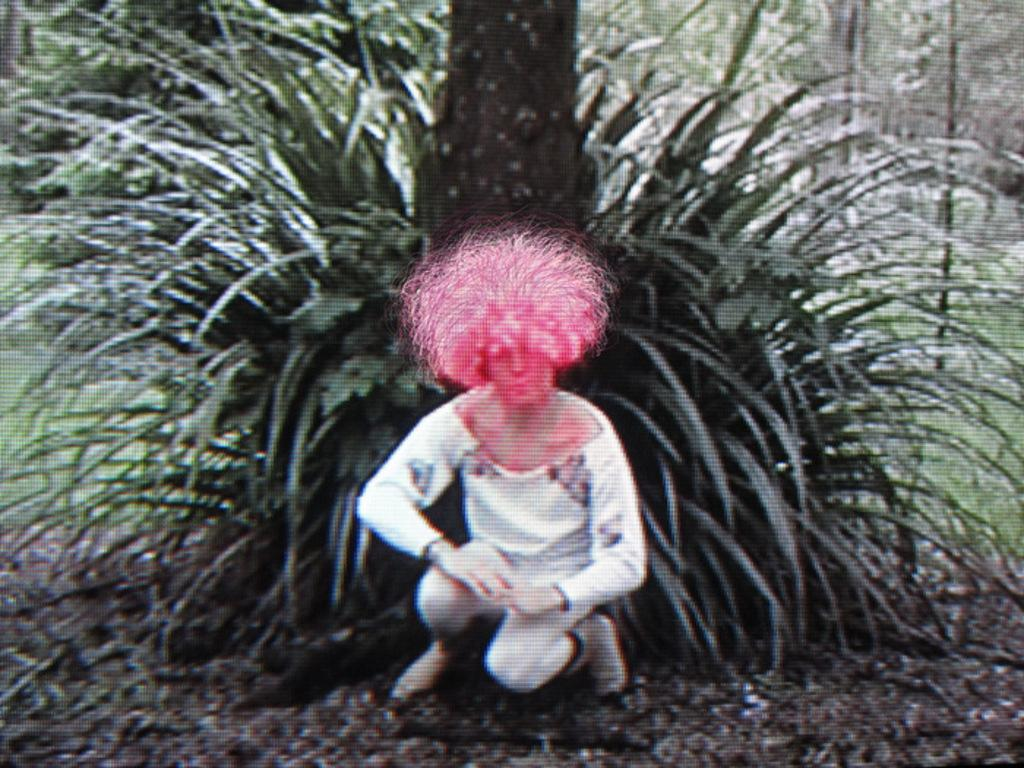What position is the person in the image? The person is sitting in a squat position. What can be seen behind the person? There is a plant, grass, and a tree trunk visible behind the person. Can you describe the vegetation behind the person? The vegetation includes a plant, grass, and a tree trunk. What type of protest is the person participating in the image? There is no protest present in the image; it only shows a person sitting in a squat position with vegetation behind them. 